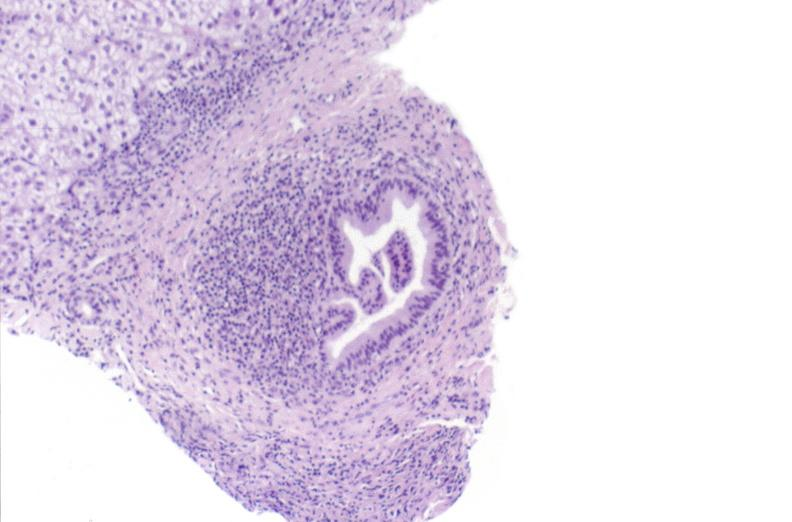s cervical leiomyoma present?
Answer the question using a single word or phrase. No 